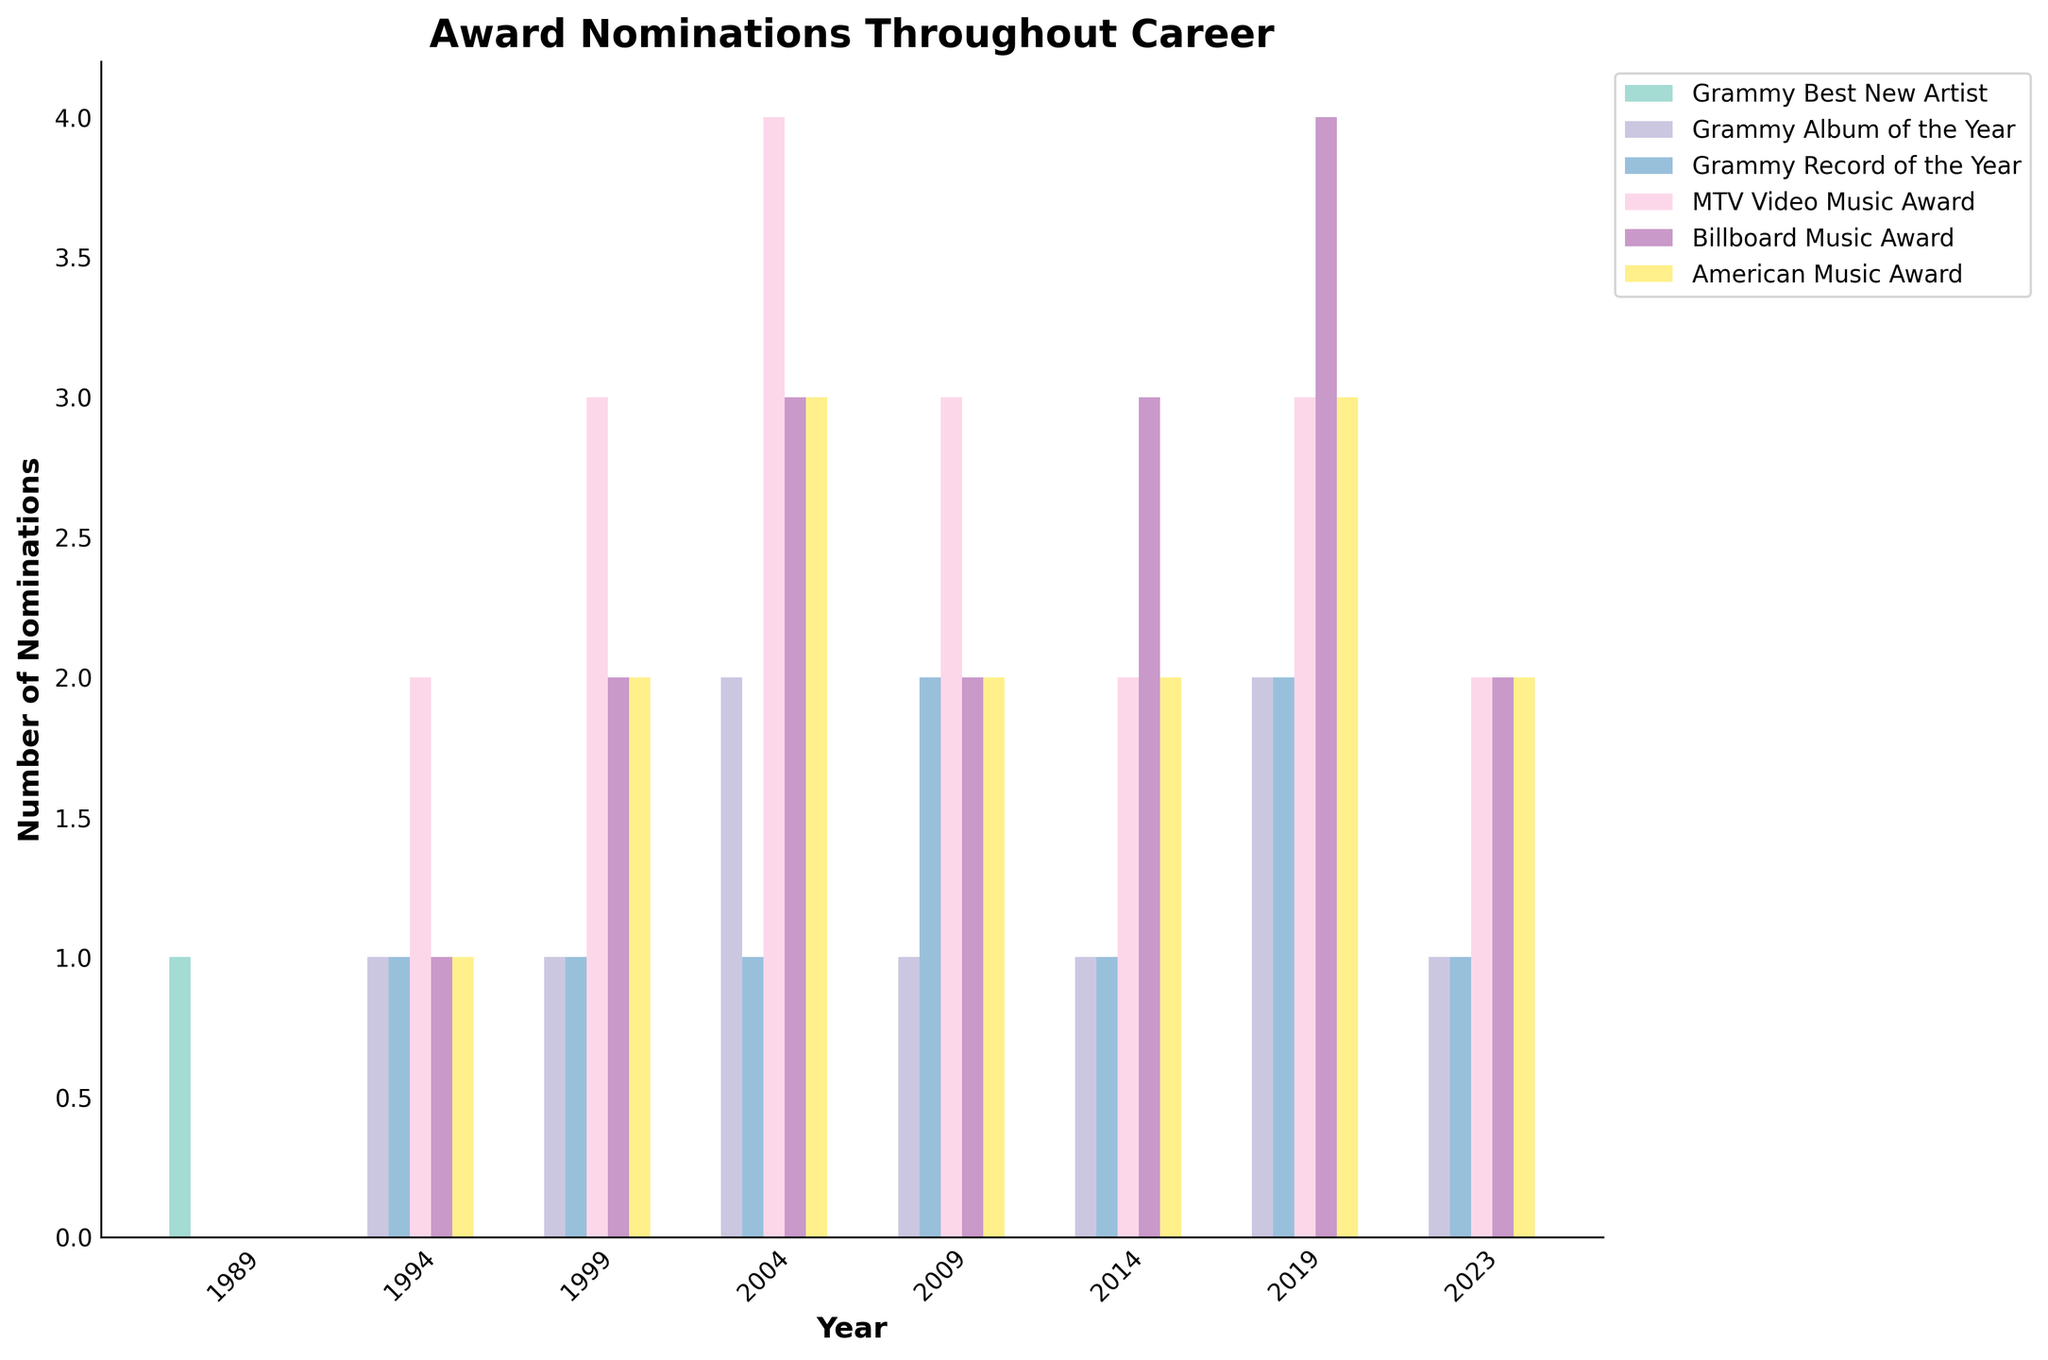How many total Grammy nominations are there in 2004? Sum the nominations for "Grammy Best New Artist," "Grammy Album of the Year," and "Grammy Record of the Year" for the year 2004. The values are 0, 2, and 1 respectively. Therefore, 0 + 2 + 1 = 3.
Answer: 3 Which year had the highest number of American Music Award nominations, and what was the total? By examining the height of the bars for "American Music Award" across the years, the year 2004 and year 2019 have the tallest bars, both having the highest value of 3.
Answer: 2019, 3 How many years had more than 2 Grammy nominations for "Grammy Album of the Year"? Checking the "Grammy Album of the Year" bars, only the years 2004 and 2019 had more than 2 nominations each (both having 2). The criteria "more than 2" means there are actually 0 years that had more than 2.
Answer: 0 In 1999, how do MTV Video Music Award nominations compare to Billboard Music Award nominations? The values for MTV Video Music Awards and Billboard Music Awards in 1999 are 3 and 2, respectively, meaning MTV Video Music Awards had more nominations than Billboard Music Awards.
Answer: MTV had more What is the trend in Grammy Record of the Year nominations from 1989 to 2023? Looking at the heights of the "Grammy Record of the Year" bars from 1989 to 2023, the values are 0, 1, 1, 1, 2, 1, 2, 1, showing fluctuations over the years without a consistent increase or decrease trend.
Answer: Fluctuates Compare the total Grammy nominations in 2009 and 2019. Which year had more, and by how many? Summing the values for "Grammy Best New Artist," "Grammy Album of the Year," and "Grammy Record of the Year" for both years. 2009 has 0 + 1 + 2 = 3, and 2019 has 0 + 2 + 2 = 4. Thus, 2019 had more by 1.
Answer: 2019 by 1 Which category saw an increase in nominations every 5 years from 1994 to 2019? For each category, check the values for the years 1994, 1999, 2004, 2009, 2014, and 2019. Only Billboard Music Awards consistently increased as 1, 2, 3, 2, 3, 4.
Answer: Billboard Music Award Was there any year where the nominations across all categories were equal? Check all nomination bars for each year: no year shows equal nominations across all categories based on the graph.
Answer: No How do American Music Award nominations in 1994 compare to those in 2023? The values are 1 in 1994 and 2 in 2023, indicating there was an increase by comparing the bars' height.
Answer: Increased In which year did the MTV Video Music Award nominations peak, and how many were there? Looking at the height of MTV bars, 2004 has the peak with 4 nominations.
Answer: 2004, 4 